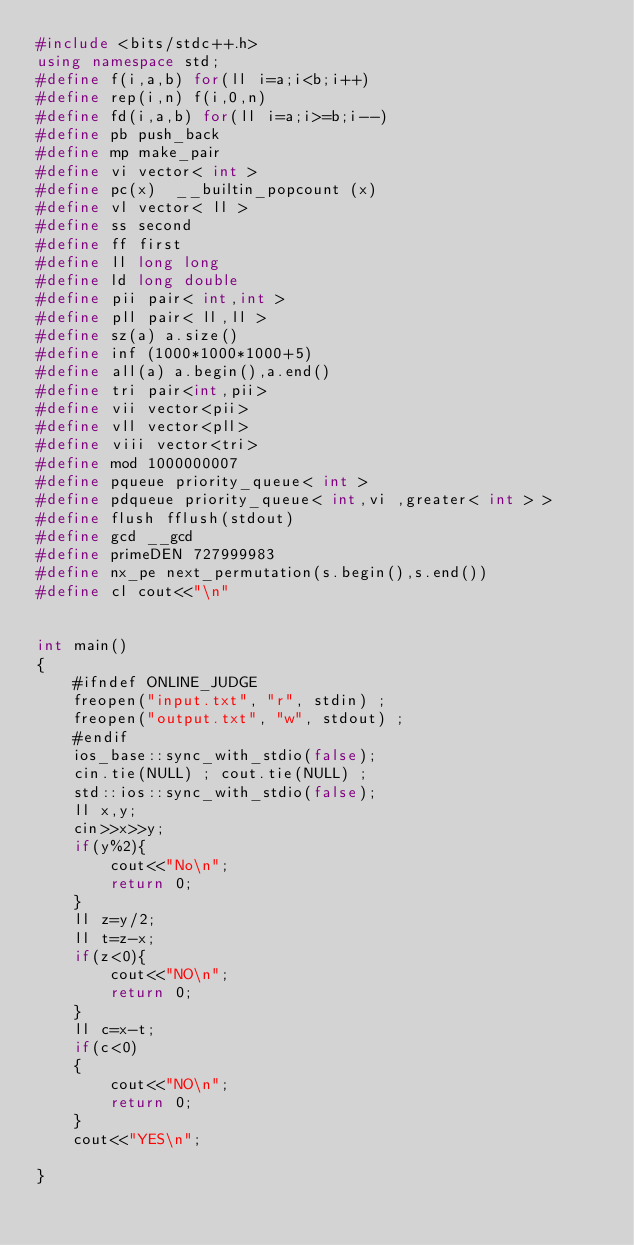<code> <loc_0><loc_0><loc_500><loc_500><_C++_>#include <bits/stdc++.h>
using namespace std;
#define f(i,a,b) for(ll i=a;i<b;i++)
#define rep(i,n) f(i,0,n)
#define fd(i,a,b) for(ll i=a;i>=b;i--)
#define pb push_back
#define mp make_pair
#define vi vector< int >
#define pc(x)  __builtin_popcount (x)
#define vl vector< ll >
#define ss second
#define ff first
#define ll long long
#define ld long double
#define pii pair< int,int >
#define pll pair< ll,ll >
#define sz(a) a.size()
#define inf (1000*1000*1000+5)
#define all(a) a.begin(),a.end()
#define tri pair<int,pii>
#define vii vector<pii>
#define vll vector<pll>
#define viii vector<tri>
#define mod 1000000007
#define pqueue priority_queue< int >
#define pdqueue priority_queue< int,vi ,greater< int > >
#define flush fflush(stdout) 
#define gcd __gcd
#define primeDEN 727999983
#define nx_pe next_permutation(s.begin(),s.end())
#define cl cout<<"\n"

    
int main()
{
    #ifndef ONLINE_JUDGE
    freopen("input.txt", "r", stdin) ;
    freopen("output.txt", "w", stdout) ;
    #endif
    ios_base::sync_with_stdio(false);
    cin.tie(NULL) ; cout.tie(NULL) ;
    std::ios::sync_with_stdio(false);
    ll x,y;
    cin>>x>>y;
    if(y%2){
        cout<<"No\n";
        return 0;
    }
    ll z=y/2;
    ll t=z-x;
    if(z<0){
        cout<<"NO\n";
        return 0;
    }
    ll c=x-t;
    if(c<0)
    {
        cout<<"NO\n";
        return 0;
    }
    cout<<"YES\n";

}


</code> 